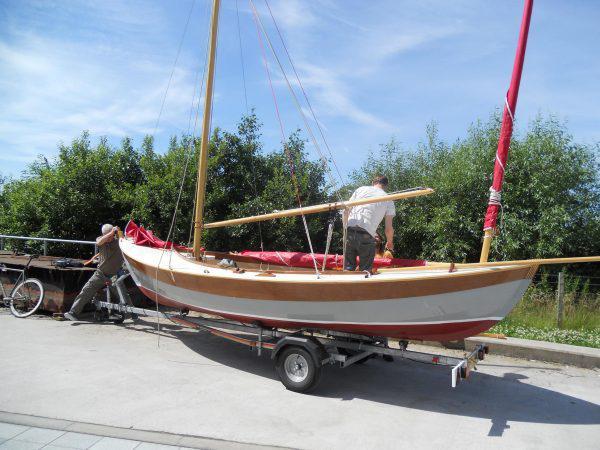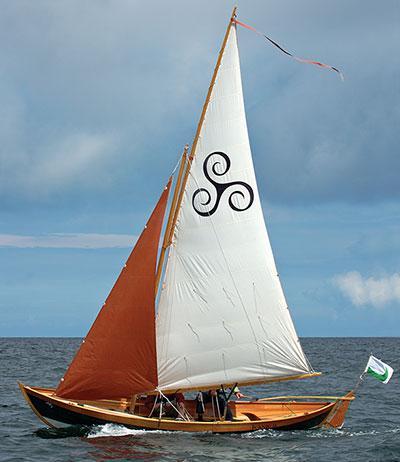The first image is the image on the left, the second image is the image on the right. Given the left and right images, does the statement "In at least one image, the trees in the background are merely a short walk away." hold true? Answer yes or no. Yes. The first image is the image on the left, the second image is the image on the right. For the images shown, is this caption "the sails in the image on the right do not have the color white on them." true? Answer yes or no. No. 